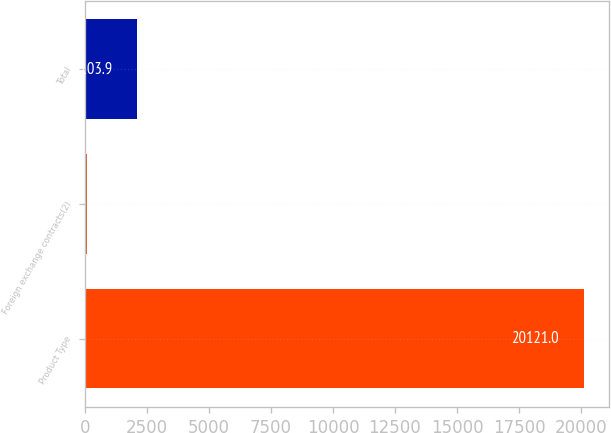Convert chart. <chart><loc_0><loc_0><loc_500><loc_500><bar_chart><fcel>Product Type<fcel>Foreign exchange contracts(2)<fcel>Total<nl><fcel>20121<fcel>102<fcel>2103.9<nl></chart> 